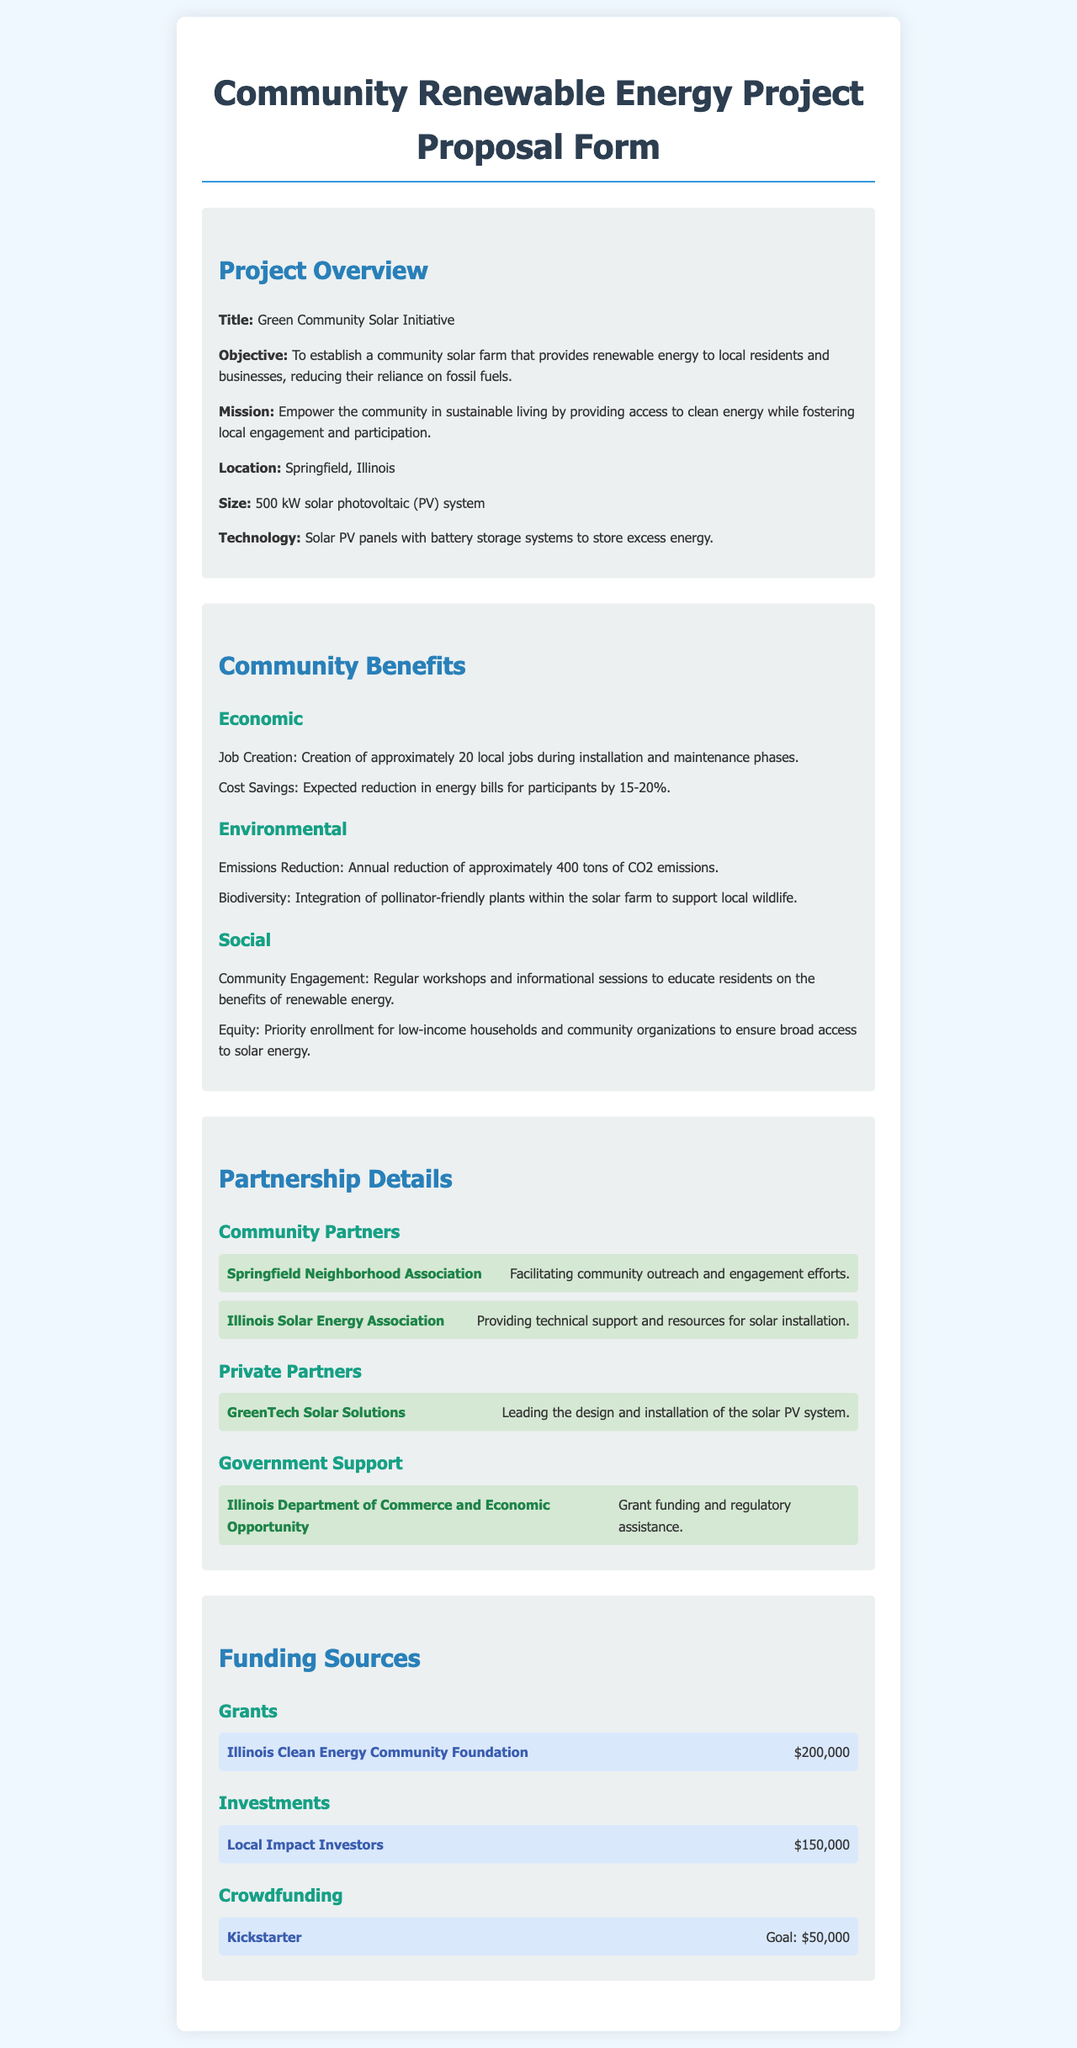what is the project title? The project title is found in the Project Overview section of the document.
Answer: Green Community Solar Initiative what is the expected reduction in energy bills? The expected reduction in energy bills is mentioned in the Community Benefits section under Economic.
Answer: 15-20% how many local jobs will be created? The number of local jobs created is specified in the Community Benefits section under Economic.
Answer: 20 what is the annual reduction of CO2 emissions? The annual reduction of CO2 emissions is provided in the Community Benefits section under Environmental.
Answer: 400 tons who is leading the design and installation of the solar PV system? The leading partner for design and installation is found in the Partnership Details section under Private Partners.
Answer: GreenTech Solar Solutions what is the funding goal for Kickstarter? The funding goal for Kickstarter is specified under the Funding Sources section for Crowdfunding.
Answer: $50,000 which government department is providing grant funding? The government department providing grant funding is mentioned in the Partnership Details section under Government Support.
Answer: Illinois Department of Commerce and Economic Opportunity what type of events will be held to engage the community? The type of events aimed at community engagement is described in the Community Benefits section under Social.
Answer: Workshops and informational sessions 